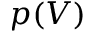<formula> <loc_0><loc_0><loc_500><loc_500>p ( V )</formula> 